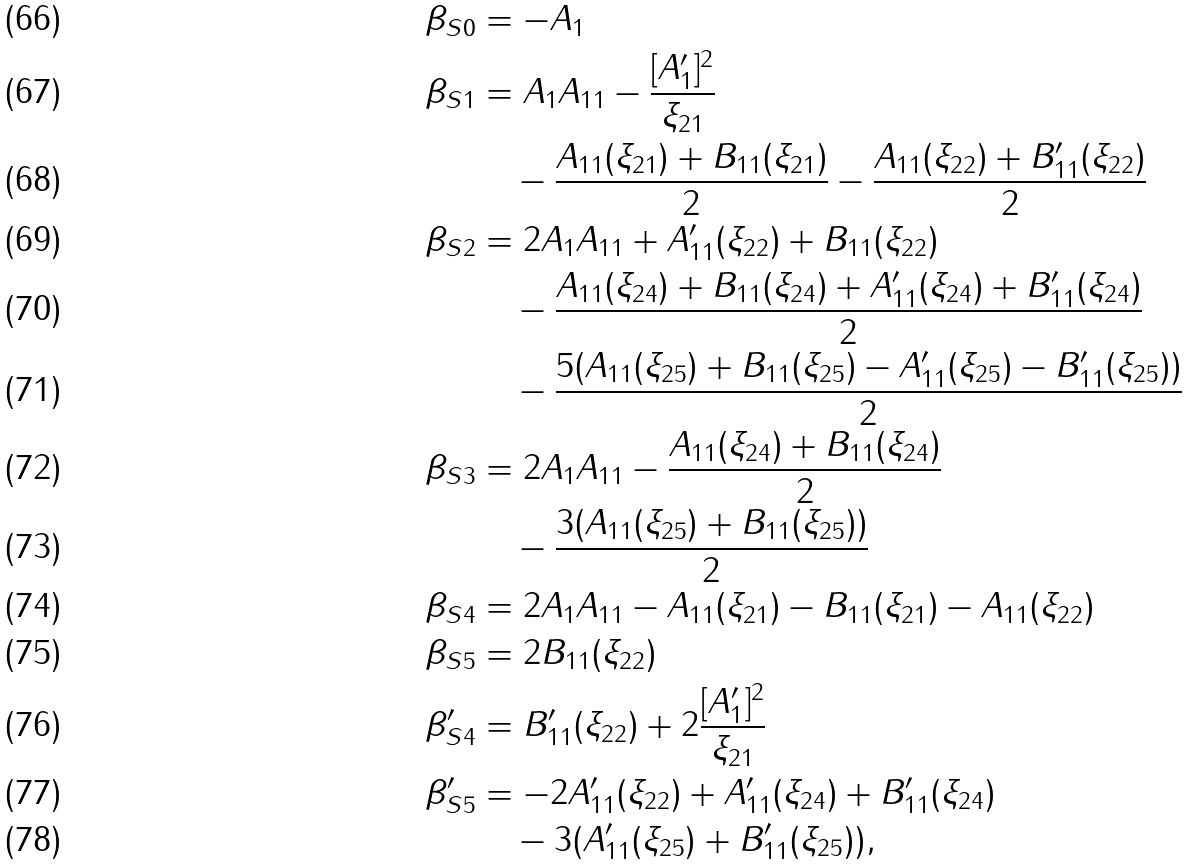Convert formula to latex. <formula><loc_0><loc_0><loc_500><loc_500>\beta _ { S 0 } & = - A _ { 1 } \\ \beta _ { S 1 } & = A _ { 1 } A _ { 1 1 } - \frac { [ A ^ { \prime } _ { 1 } ] ^ { 2 } } { \xi _ { 2 1 } } \\ & \quad - \frac { A _ { 1 1 } ( \xi _ { 2 1 } ) + B _ { 1 1 } ( \xi _ { 2 1 } ) } { 2 } - \frac { A _ { 1 1 } ( \xi _ { 2 2 } ) + B ^ { \prime } _ { 1 1 } ( \xi _ { 2 2 } ) } { 2 } \\ \beta _ { S 2 } & = 2 A _ { 1 } A _ { 1 1 } + A ^ { \prime } _ { 1 1 } ( \xi _ { 2 2 } ) + B _ { 1 1 } ( \xi _ { 2 2 } ) \\ & \quad - \frac { A _ { 1 1 } ( \xi _ { 2 4 } ) + B _ { 1 1 } ( \xi _ { 2 4 } ) + A ^ { \prime } _ { 1 1 } ( \xi _ { 2 4 } ) + B ^ { \prime } _ { 1 1 } ( \xi _ { 2 4 } ) } { 2 } \\ & \quad - \frac { 5 ( A _ { 1 1 } ( \xi _ { 2 5 } ) + B _ { 1 1 } ( \xi _ { 2 5 } ) - A ^ { \prime } _ { 1 1 } ( \xi _ { 2 5 } ) - B ^ { \prime } _ { 1 1 } ( \xi _ { 2 5 } ) ) } { 2 } \\ \beta _ { S 3 } & = 2 A _ { 1 } A _ { 1 1 } - \frac { A _ { 1 1 } ( \xi _ { 2 4 } ) + B _ { 1 1 } ( \xi _ { 2 4 } ) } { 2 } \\ & \quad - \frac { 3 ( A _ { 1 1 } ( \xi _ { 2 5 } ) + B _ { 1 1 } ( \xi _ { 2 5 } ) ) } { 2 } \\ \beta _ { S 4 } & = 2 A _ { 1 } A _ { 1 1 } - A _ { 1 1 } ( \xi _ { 2 1 } ) - B _ { 1 1 } ( \xi _ { 2 1 } ) - A _ { 1 1 } ( \xi _ { 2 2 } ) \\ \beta _ { S 5 } & = 2 B _ { 1 1 } ( \xi _ { 2 2 } ) \\ \beta ^ { \prime } _ { S 4 } & = B ^ { \prime } _ { 1 1 } ( \xi _ { 2 2 } ) + 2 \frac { [ A ^ { \prime } _ { 1 } ] ^ { 2 } } { \xi _ { 2 1 } } \\ \beta ^ { \prime } _ { S 5 } & = - 2 A ^ { \prime } _ { 1 1 } ( \xi _ { 2 2 } ) + A ^ { \prime } _ { 1 1 } ( \xi _ { 2 4 } ) + B ^ { \prime } _ { 1 1 } ( \xi _ { 2 4 } ) \\ & \quad - 3 ( A ^ { \prime } _ { 1 1 } ( \xi _ { 2 5 } ) + B ^ { \prime } _ { 1 1 } ( \xi _ { 2 5 } ) ) ,</formula> 